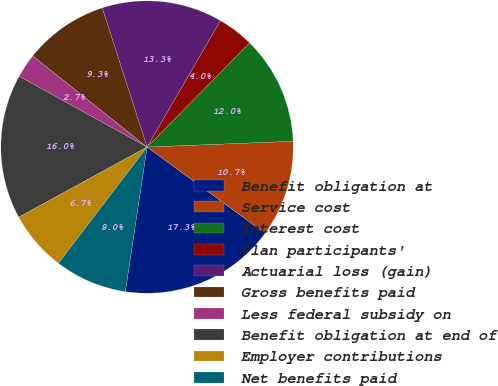<chart> <loc_0><loc_0><loc_500><loc_500><pie_chart><fcel>Benefit obligation at<fcel>Service cost<fcel>Interest cost<fcel>Plan participants'<fcel>Actuarial loss (gain)<fcel>Gross benefits paid<fcel>Less federal subsidy on<fcel>Benefit obligation at end of<fcel>Employer contributions<fcel>Net benefits paid<nl><fcel>17.33%<fcel>10.67%<fcel>12.0%<fcel>4.0%<fcel>13.33%<fcel>9.33%<fcel>2.67%<fcel>16.0%<fcel>6.67%<fcel>8.0%<nl></chart> 